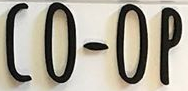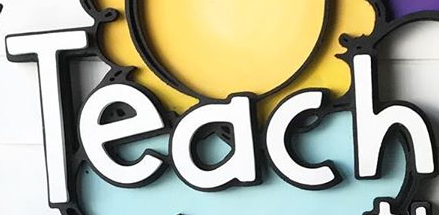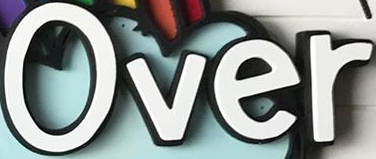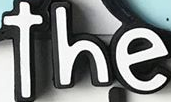Identify the words shown in these images in order, separated by a semicolon. CO-OP; Teach; Over; the 